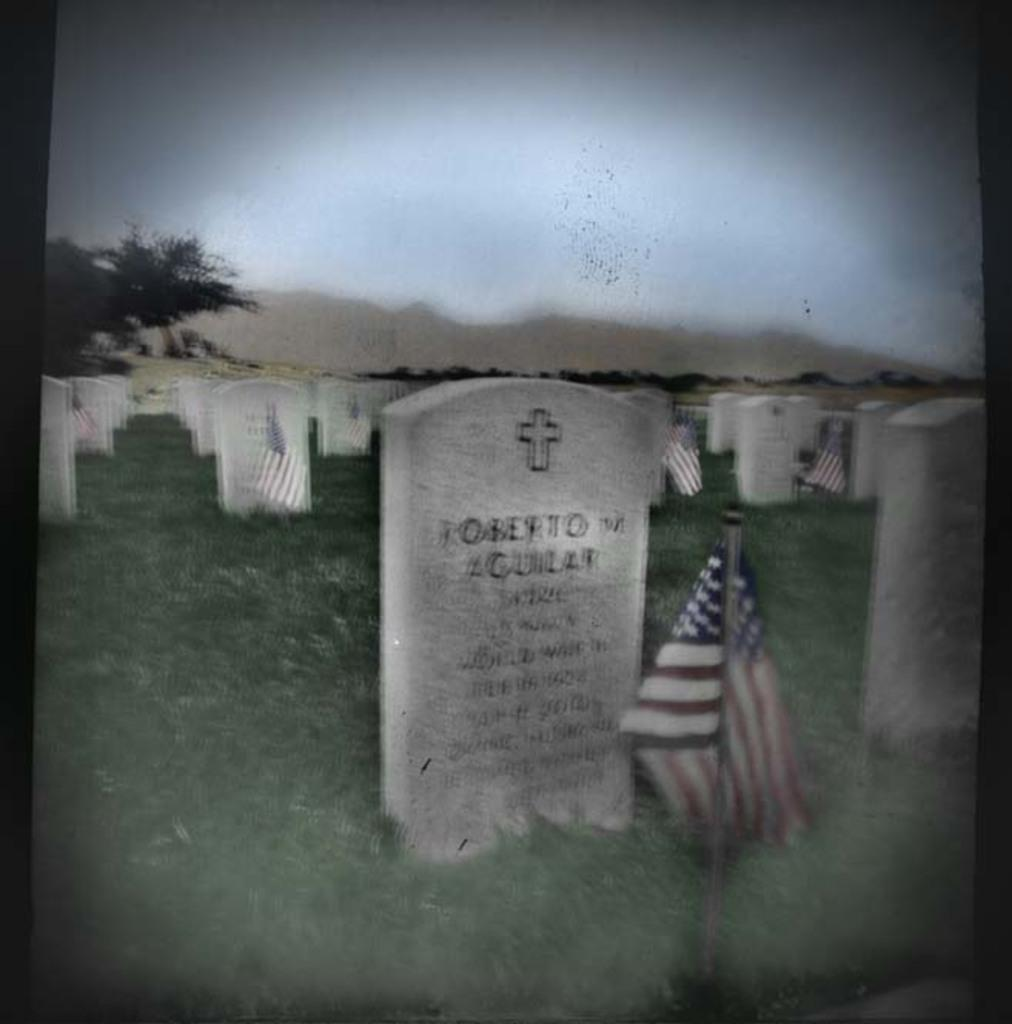What type of structures can be seen in the image? There are graves in the image. What is the other object visible in the image? There is a flag in the image. What type of vegetation is present at the bottom of the image? There is grass at the bottom of the image. What can be seen on the left side of the image? There are trees on the left side of the image. What is visible at the top of the image? The sky is visible at the top of the image. How many beads are hanging from the trees in the image? There are no beads present in the image; it features graves, a flag, grass, trees, and the sky. What type of slave is depicted in the image? There is no depiction of a slave in the image; it features graves, a flag, grass, trees, and the sky. 